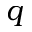<formula> <loc_0><loc_0><loc_500><loc_500>q</formula> 